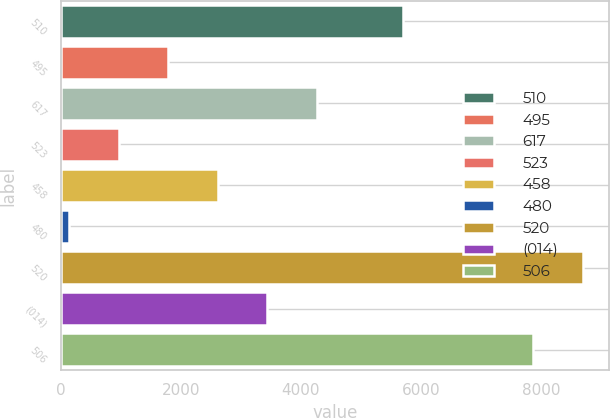Convert chart to OTSL. <chart><loc_0><loc_0><loc_500><loc_500><bar_chart><fcel>510<fcel>495<fcel>617<fcel>523<fcel>458<fcel>480<fcel>520<fcel>(014)<fcel>506<nl><fcel>5700<fcel>1788.2<fcel>4266.5<fcel>962.1<fcel>2614.3<fcel>136<fcel>8702.1<fcel>3440.4<fcel>7876<nl></chart> 